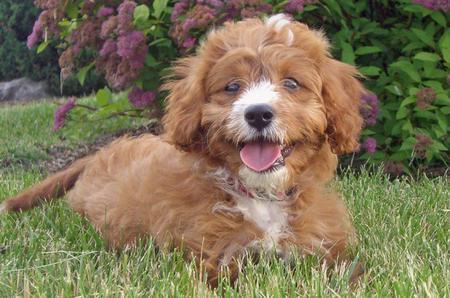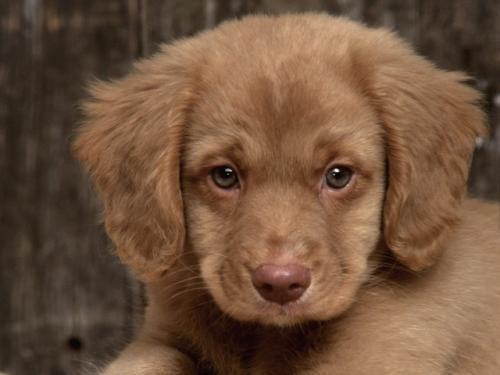The first image is the image on the left, the second image is the image on the right. Examine the images to the left and right. Is the description "The left and right image contains the same number of puppies." accurate? Answer yes or no. Yes. The first image is the image on the left, the second image is the image on the right. Evaluate the accuracy of this statement regarding the images: "A dog is laying in grass.". Is it true? Answer yes or no. Yes. 